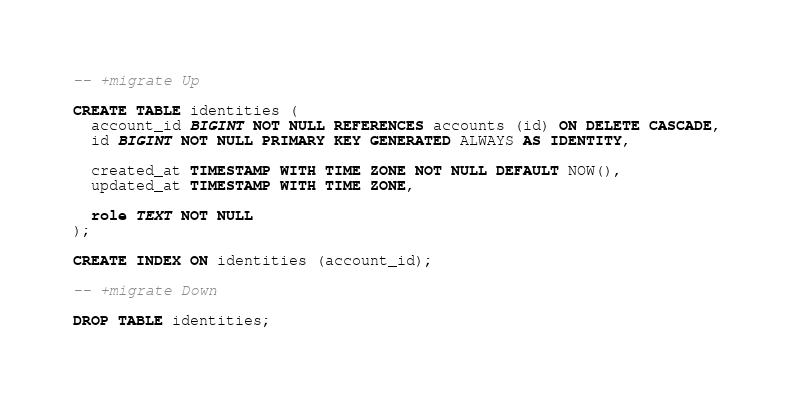Convert code to text. <code><loc_0><loc_0><loc_500><loc_500><_SQL_>-- +migrate Up

CREATE TABLE identities (
  account_id BIGINT NOT NULL REFERENCES accounts (id) ON DELETE CASCADE,
  id BIGINT NOT NULL PRIMARY KEY GENERATED ALWAYS AS IDENTITY,

  created_at TIMESTAMP WITH TIME ZONE NOT NULL DEFAULT NOW(),
  updated_at TIMESTAMP WITH TIME ZONE,

  role TEXT NOT NULL
);

CREATE INDEX ON identities (account_id);

-- +migrate Down

DROP TABLE identities;
</code> 